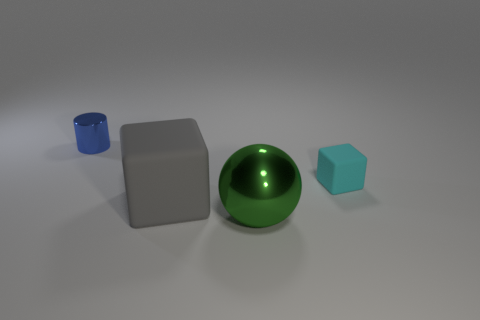Subtract all cylinders. How many objects are left? 3 Subtract 2 blocks. How many blocks are left? 0 Subtract all purple balls. Subtract all cyan cubes. How many balls are left? 1 Subtract all purple cubes. How many cyan balls are left? 0 Subtract all large cyan shiny balls. Subtract all big cubes. How many objects are left? 3 Add 2 tiny blue metal cylinders. How many tiny blue metal cylinders are left? 3 Add 2 red rubber cylinders. How many red rubber cylinders exist? 2 Add 4 large green metal balls. How many objects exist? 8 Subtract 0 red spheres. How many objects are left? 4 